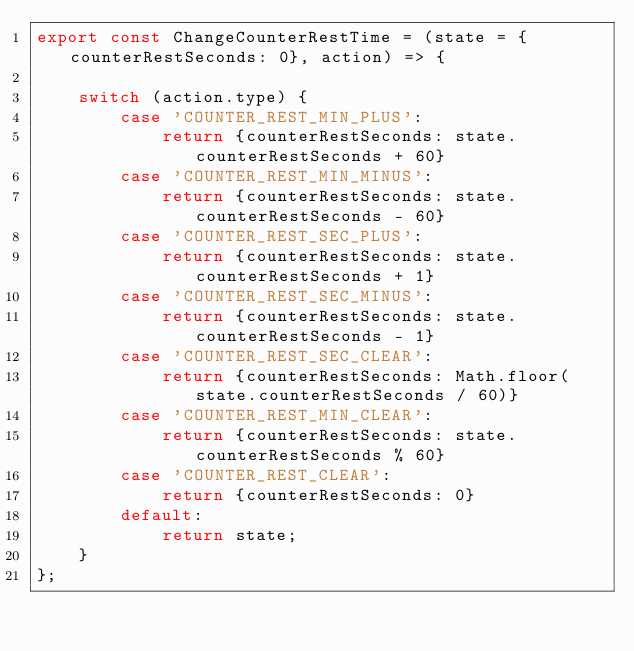Convert code to text. <code><loc_0><loc_0><loc_500><loc_500><_JavaScript_>export const ChangeCounterRestTime = (state = {counterRestSeconds: 0}, action) => {

    switch (action.type) {
        case 'COUNTER_REST_MIN_PLUS':
            return {counterRestSeconds: state.counterRestSeconds + 60}
        case 'COUNTER_REST_MIN_MINUS':
            return {counterRestSeconds: state.counterRestSeconds - 60}
        case 'COUNTER_REST_SEC_PLUS':
            return {counterRestSeconds: state.counterRestSeconds + 1}
        case 'COUNTER_REST_SEC_MINUS':
            return {counterRestSeconds: state.counterRestSeconds - 1}
        case 'COUNTER_REST_SEC_CLEAR':
            return {counterRestSeconds: Math.floor(state.counterRestSeconds / 60)}
        case 'COUNTER_REST_MIN_CLEAR':
            return {counterRestSeconds: state.counterRestSeconds % 60}
        case 'COUNTER_REST_CLEAR':
            return {counterRestSeconds: 0}
        default:
            return state;
    }
};</code> 